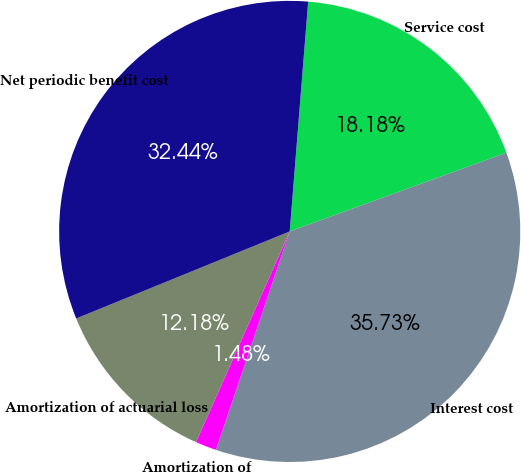Convert chart to OTSL. <chart><loc_0><loc_0><loc_500><loc_500><pie_chart><fcel>Service cost<fcel>Interest cost<fcel>Amortization of<fcel>Amortization of actuarial loss<fcel>Net periodic benefit cost<nl><fcel>18.18%<fcel>35.73%<fcel>1.48%<fcel>12.18%<fcel>32.44%<nl></chart> 